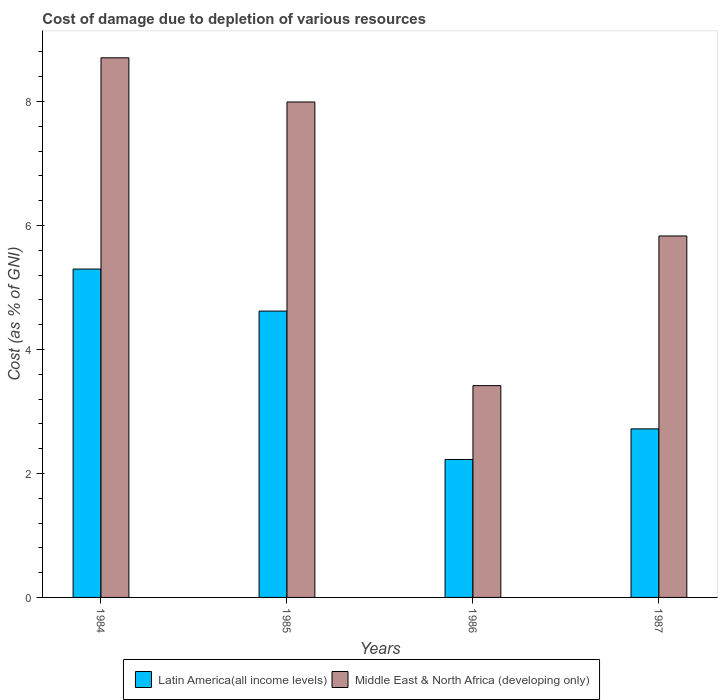How many different coloured bars are there?
Offer a terse response. 2. How many groups of bars are there?
Keep it short and to the point. 4. How many bars are there on the 4th tick from the left?
Make the answer very short. 2. How many bars are there on the 1st tick from the right?
Your response must be concise. 2. What is the label of the 1st group of bars from the left?
Make the answer very short. 1984. What is the cost of damage caused due to the depletion of various resources in Latin America(all income levels) in 1985?
Provide a succinct answer. 4.62. Across all years, what is the maximum cost of damage caused due to the depletion of various resources in Middle East & North Africa (developing only)?
Keep it short and to the point. 8.7. Across all years, what is the minimum cost of damage caused due to the depletion of various resources in Latin America(all income levels)?
Your answer should be compact. 2.23. In which year was the cost of damage caused due to the depletion of various resources in Middle East & North Africa (developing only) minimum?
Your answer should be compact. 1986. What is the total cost of damage caused due to the depletion of various resources in Middle East & North Africa (developing only) in the graph?
Give a very brief answer. 25.94. What is the difference between the cost of damage caused due to the depletion of various resources in Middle East & North Africa (developing only) in 1985 and that in 1986?
Keep it short and to the point. 4.58. What is the difference between the cost of damage caused due to the depletion of various resources in Middle East & North Africa (developing only) in 1987 and the cost of damage caused due to the depletion of various resources in Latin America(all income levels) in 1984?
Give a very brief answer. 0.53. What is the average cost of damage caused due to the depletion of various resources in Middle East & North Africa (developing only) per year?
Provide a succinct answer. 6.49. In the year 1986, what is the difference between the cost of damage caused due to the depletion of various resources in Middle East & North Africa (developing only) and cost of damage caused due to the depletion of various resources in Latin America(all income levels)?
Offer a very short reply. 1.19. What is the ratio of the cost of damage caused due to the depletion of various resources in Middle East & North Africa (developing only) in 1984 to that in 1985?
Offer a terse response. 1.09. What is the difference between the highest and the second highest cost of damage caused due to the depletion of various resources in Latin America(all income levels)?
Make the answer very short. 0.68. What is the difference between the highest and the lowest cost of damage caused due to the depletion of various resources in Latin America(all income levels)?
Ensure brevity in your answer.  3.07. Is the sum of the cost of damage caused due to the depletion of various resources in Latin America(all income levels) in 1984 and 1986 greater than the maximum cost of damage caused due to the depletion of various resources in Middle East & North Africa (developing only) across all years?
Ensure brevity in your answer.  No. What does the 1st bar from the left in 1984 represents?
Your answer should be compact. Latin America(all income levels). What does the 1st bar from the right in 1984 represents?
Your response must be concise. Middle East & North Africa (developing only). How many bars are there?
Keep it short and to the point. 8. How many years are there in the graph?
Offer a terse response. 4. Are the values on the major ticks of Y-axis written in scientific E-notation?
Make the answer very short. No. Does the graph contain any zero values?
Offer a very short reply. No. Where does the legend appear in the graph?
Provide a succinct answer. Bottom center. What is the title of the graph?
Ensure brevity in your answer.  Cost of damage due to depletion of various resources. What is the label or title of the X-axis?
Keep it short and to the point. Years. What is the label or title of the Y-axis?
Provide a short and direct response. Cost (as % of GNI). What is the Cost (as % of GNI) in Latin America(all income levels) in 1984?
Ensure brevity in your answer.  5.3. What is the Cost (as % of GNI) in Middle East & North Africa (developing only) in 1984?
Make the answer very short. 8.7. What is the Cost (as % of GNI) in Latin America(all income levels) in 1985?
Offer a terse response. 4.62. What is the Cost (as % of GNI) of Middle East & North Africa (developing only) in 1985?
Provide a short and direct response. 7.99. What is the Cost (as % of GNI) in Latin America(all income levels) in 1986?
Your response must be concise. 2.23. What is the Cost (as % of GNI) in Middle East & North Africa (developing only) in 1986?
Your answer should be very brief. 3.42. What is the Cost (as % of GNI) of Latin America(all income levels) in 1987?
Offer a terse response. 2.72. What is the Cost (as % of GNI) in Middle East & North Africa (developing only) in 1987?
Make the answer very short. 5.83. Across all years, what is the maximum Cost (as % of GNI) in Latin America(all income levels)?
Make the answer very short. 5.3. Across all years, what is the maximum Cost (as % of GNI) in Middle East & North Africa (developing only)?
Give a very brief answer. 8.7. Across all years, what is the minimum Cost (as % of GNI) of Latin America(all income levels)?
Offer a terse response. 2.23. Across all years, what is the minimum Cost (as % of GNI) in Middle East & North Africa (developing only)?
Offer a terse response. 3.42. What is the total Cost (as % of GNI) in Latin America(all income levels) in the graph?
Your answer should be very brief. 14.86. What is the total Cost (as % of GNI) in Middle East & North Africa (developing only) in the graph?
Make the answer very short. 25.94. What is the difference between the Cost (as % of GNI) in Latin America(all income levels) in 1984 and that in 1985?
Give a very brief answer. 0.68. What is the difference between the Cost (as % of GNI) of Middle East & North Africa (developing only) in 1984 and that in 1985?
Provide a succinct answer. 0.71. What is the difference between the Cost (as % of GNI) in Latin America(all income levels) in 1984 and that in 1986?
Give a very brief answer. 3.07. What is the difference between the Cost (as % of GNI) of Middle East & North Africa (developing only) in 1984 and that in 1986?
Your response must be concise. 5.29. What is the difference between the Cost (as % of GNI) of Latin America(all income levels) in 1984 and that in 1987?
Provide a succinct answer. 2.58. What is the difference between the Cost (as % of GNI) of Middle East & North Africa (developing only) in 1984 and that in 1987?
Offer a very short reply. 2.87. What is the difference between the Cost (as % of GNI) in Latin America(all income levels) in 1985 and that in 1986?
Make the answer very short. 2.39. What is the difference between the Cost (as % of GNI) of Middle East & North Africa (developing only) in 1985 and that in 1986?
Your answer should be very brief. 4.58. What is the difference between the Cost (as % of GNI) of Latin America(all income levels) in 1985 and that in 1987?
Give a very brief answer. 1.9. What is the difference between the Cost (as % of GNI) of Middle East & North Africa (developing only) in 1985 and that in 1987?
Offer a terse response. 2.16. What is the difference between the Cost (as % of GNI) in Latin America(all income levels) in 1986 and that in 1987?
Ensure brevity in your answer.  -0.49. What is the difference between the Cost (as % of GNI) in Middle East & North Africa (developing only) in 1986 and that in 1987?
Offer a very short reply. -2.41. What is the difference between the Cost (as % of GNI) in Latin America(all income levels) in 1984 and the Cost (as % of GNI) in Middle East & North Africa (developing only) in 1985?
Your answer should be compact. -2.69. What is the difference between the Cost (as % of GNI) in Latin America(all income levels) in 1984 and the Cost (as % of GNI) in Middle East & North Africa (developing only) in 1986?
Keep it short and to the point. 1.88. What is the difference between the Cost (as % of GNI) of Latin America(all income levels) in 1984 and the Cost (as % of GNI) of Middle East & North Africa (developing only) in 1987?
Provide a short and direct response. -0.53. What is the difference between the Cost (as % of GNI) of Latin America(all income levels) in 1985 and the Cost (as % of GNI) of Middle East & North Africa (developing only) in 1986?
Your answer should be compact. 1.2. What is the difference between the Cost (as % of GNI) in Latin America(all income levels) in 1985 and the Cost (as % of GNI) in Middle East & North Africa (developing only) in 1987?
Offer a terse response. -1.21. What is the difference between the Cost (as % of GNI) in Latin America(all income levels) in 1986 and the Cost (as % of GNI) in Middle East & North Africa (developing only) in 1987?
Provide a succinct answer. -3.6. What is the average Cost (as % of GNI) of Latin America(all income levels) per year?
Ensure brevity in your answer.  3.71. What is the average Cost (as % of GNI) in Middle East & North Africa (developing only) per year?
Provide a succinct answer. 6.49. In the year 1984, what is the difference between the Cost (as % of GNI) of Latin America(all income levels) and Cost (as % of GNI) of Middle East & North Africa (developing only)?
Keep it short and to the point. -3.41. In the year 1985, what is the difference between the Cost (as % of GNI) in Latin America(all income levels) and Cost (as % of GNI) in Middle East & North Africa (developing only)?
Give a very brief answer. -3.37. In the year 1986, what is the difference between the Cost (as % of GNI) in Latin America(all income levels) and Cost (as % of GNI) in Middle East & North Africa (developing only)?
Make the answer very short. -1.19. In the year 1987, what is the difference between the Cost (as % of GNI) in Latin America(all income levels) and Cost (as % of GNI) in Middle East & North Africa (developing only)?
Provide a succinct answer. -3.11. What is the ratio of the Cost (as % of GNI) in Latin America(all income levels) in 1984 to that in 1985?
Ensure brevity in your answer.  1.15. What is the ratio of the Cost (as % of GNI) of Middle East & North Africa (developing only) in 1984 to that in 1985?
Provide a succinct answer. 1.09. What is the ratio of the Cost (as % of GNI) of Latin America(all income levels) in 1984 to that in 1986?
Provide a succinct answer. 2.38. What is the ratio of the Cost (as % of GNI) of Middle East & North Africa (developing only) in 1984 to that in 1986?
Offer a very short reply. 2.55. What is the ratio of the Cost (as % of GNI) in Latin America(all income levels) in 1984 to that in 1987?
Ensure brevity in your answer.  1.95. What is the ratio of the Cost (as % of GNI) of Middle East & North Africa (developing only) in 1984 to that in 1987?
Your answer should be very brief. 1.49. What is the ratio of the Cost (as % of GNI) of Latin America(all income levels) in 1985 to that in 1986?
Ensure brevity in your answer.  2.08. What is the ratio of the Cost (as % of GNI) in Middle East & North Africa (developing only) in 1985 to that in 1986?
Keep it short and to the point. 2.34. What is the ratio of the Cost (as % of GNI) of Latin America(all income levels) in 1985 to that in 1987?
Your answer should be compact. 1.7. What is the ratio of the Cost (as % of GNI) of Middle East & North Africa (developing only) in 1985 to that in 1987?
Your answer should be very brief. 1.37. What is the ratio of the Cost (as % of GNI) in Latin America(all income levels) in 1986 to that in 1987?
Your answer should be compact. 0.82. What is the ratio of the Cost (as % of GNI) of Middle East & North Africa (developing only) in 1986 to that in 1987?
Offer a very short reply. 0.59. What is the difference between the highest and the second highest Cost (as % of GNI) of Latin America(all income levels)?
Ensure brevity in your answer.  0.68. What is the difference between the highest and the second highest Cost (as % of GNI) of Middle East & North Africa (developing only)?
Make the answer very short. 0.71. What is the difference between the highest and the lowest Cost (as % of GNI) in Latin America(all income levels)?
Provide a short and direct response. 3.07. What is the difference between the highest and the lowest Cost (as % of GNI) in Middle East & North Africa (developing only)?
Give a very brief answer. 5.29. 